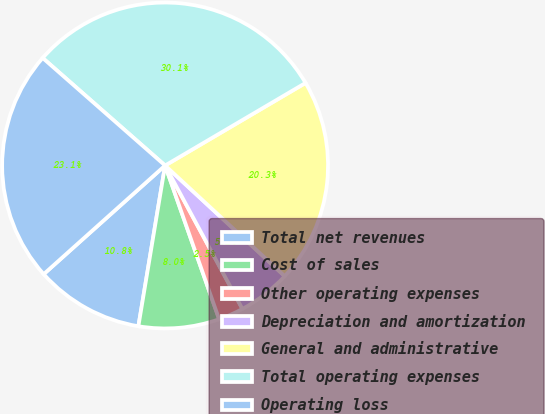Convert chart. <chart><loc_0><loc_0><loc_500><loc_500><pie_chart><fcel>Total net revenues<fcel>Cost of sales<fcel>Other operating expenses<fcel>Depreciation and amortization<fcel>General and administrative<fcel>Total operating expenses<fcel>Operating loss<nl><fcel>10.76%<fcel>8.0%<fcel>2.49%<fcel>5.25%<fcel>20.34%<fcel>30.07%<fcel>23.09%<nl></chart> 